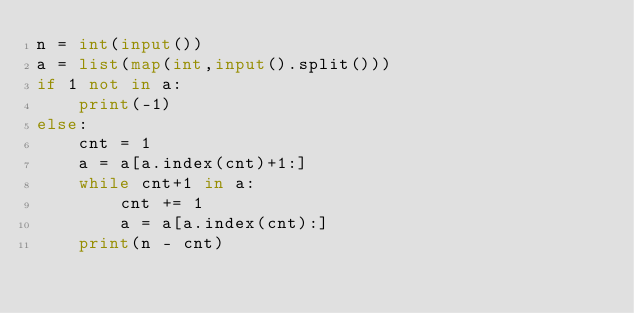<code> <loc_0><loc_0><loc_500><loc_500><_Python_>n = int(input())
a = list(map(int,input().split()))
if 1 not in a: 
    print(-1)
else:
    cnt = 1
    a = a[a.index(cnt)+1:]
    while cnt+1 in a:
        cnt += 1 
        a = a[a.index(cnt):]
    print(n - cnt)</code> 